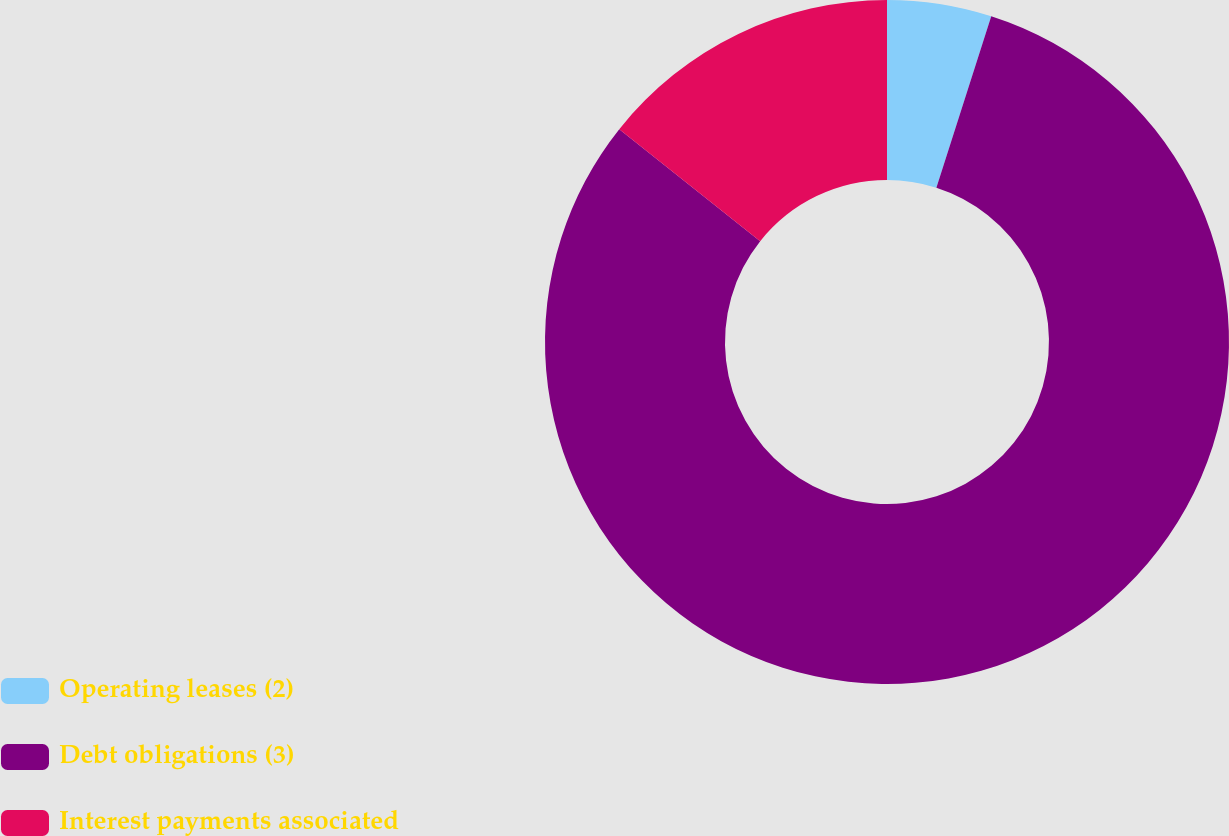<chart> <loc_0><loc_0><loc_500><loc_500><pie_chart><fcel>Operating leases (2)<fcel>Debt obligations (3)<fcel>Interest payments associated<nl><fcel>4.93%<fcel>80.76%<fcel>14.31%<nl></chart> 